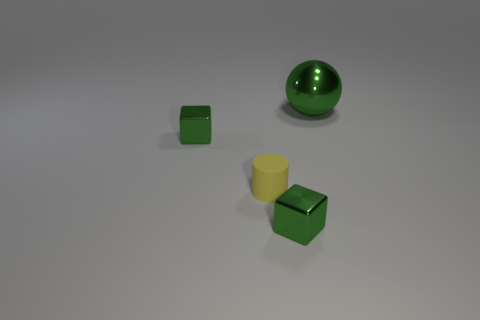Is there anything else that has the same material as the yellow cylinder?
Your answer should be compact. No. How many green things are both to the right of the small rubber cylinder and on the left side of the large object?
Your answer should be compact. 1. The tiny metal thing left of the cube that is in front of the small cylinder is what color?
Provide a short and direct response. Green. Is the shape of the big thing the same as the small green metallic object in front of the small rubber object?
Give a very brief answer. No. What material is the object behind the tiny green thing behind the green metallic object in front of the cylinder?
Offer a terse response. Metal. Is there a green metal object of the same size as the yellow cylinder?
Give a very brief answer. Yes. What shape is the small yellow thing?
Make the answer very short. Cylinder. Is the yellow thing made of the same material as the tiny green block on the left side of the small matte thing?
Give a very brief answer. No. What number of objects are either tiny green cubes or tiny gray matte objects?
Your answer should be compact. 2. Are there any cyan matte cubes?
Your answer should be very brief. No. 